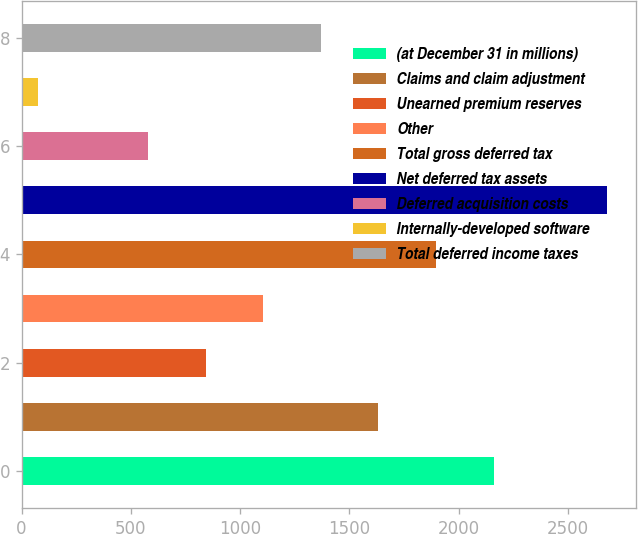Convert chart to OTSL. <chart><loc_0><loc_0><loc_500><loc_500><bar_chart><fcel>(at December 31 in millions)<fcel>Claims and claim adjustment<fcel>Unearned premium reserves<fcel>Other<fcel>Total gross deferred tax<fcel>Net deferred tax assets<fcel>Deferred acquisition costs<fcel>Internally-developed software<fcel>Total deferred income taxes<nl><fcel>2159.6<fcel>1632.4<fcel>841.6<fcel>1105.2<fcel>1896<fcel>2677<fcel>578<fcel>77<fcel>1368.8<nl></chart> 